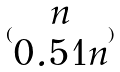<formula> <loc_0><loc_0><loc_500><loc_500>( \begin{matrix} n \\ 0 . 5 1 n \end{matrix} )</formula> 